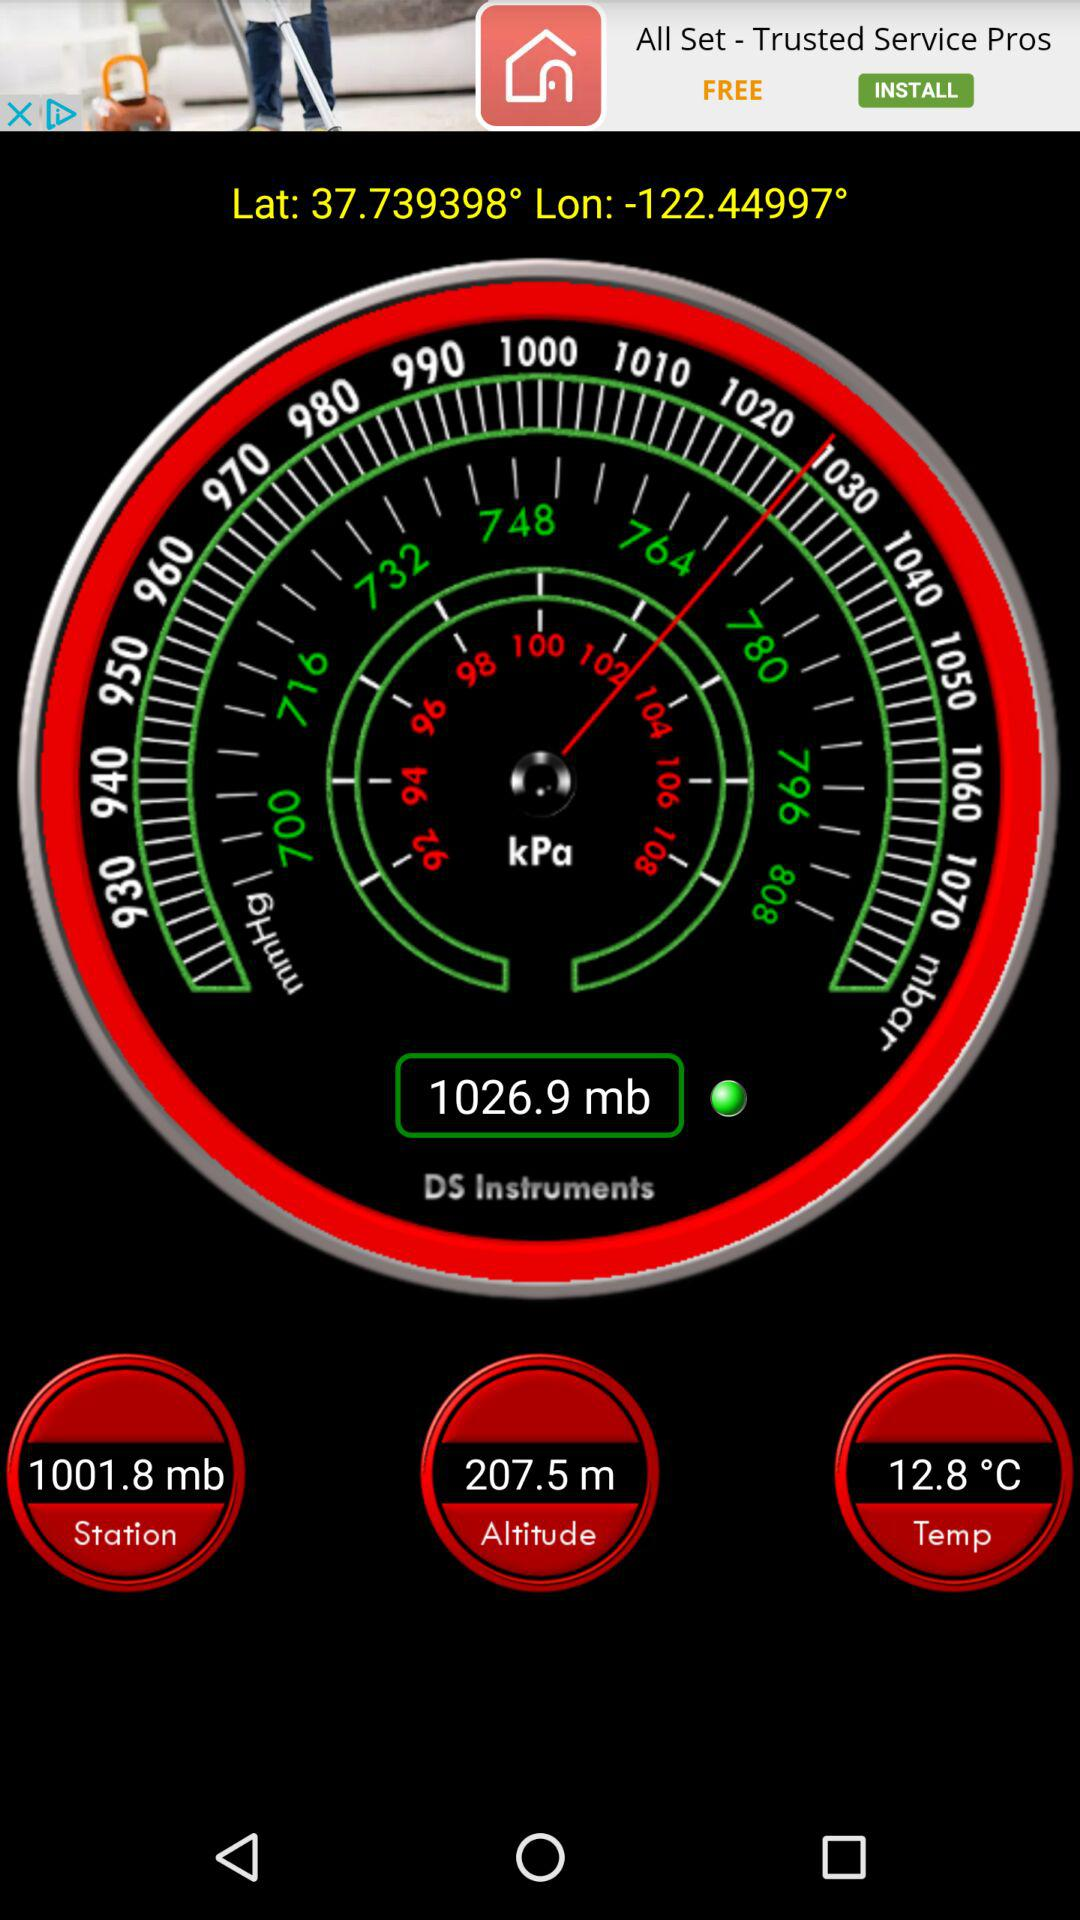What is the value of atmospheric pressure at the station? The value of atmospheric pressure at the station is 1001.8 mb. 